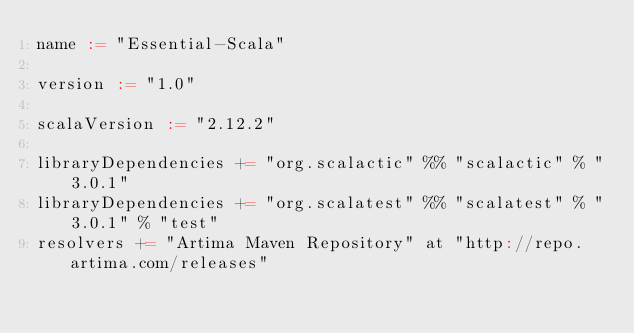Convert code to text. <code><loc_0><loc_0><loc_500><loc_500><_Scala_>name := "Essential-Scala"

version := "1.0"

scalaVersion := "2.12.2"

libraryDependencies += "org.scalactic" %% "scalactic" % "3.0.1"
libraryDependencies += "org.scalatest" %% "scalatest" % "3.0.1" % "test"
resolvers += "Artima Maven Repository" at "http://repo.artima.com/releases"
</code> 